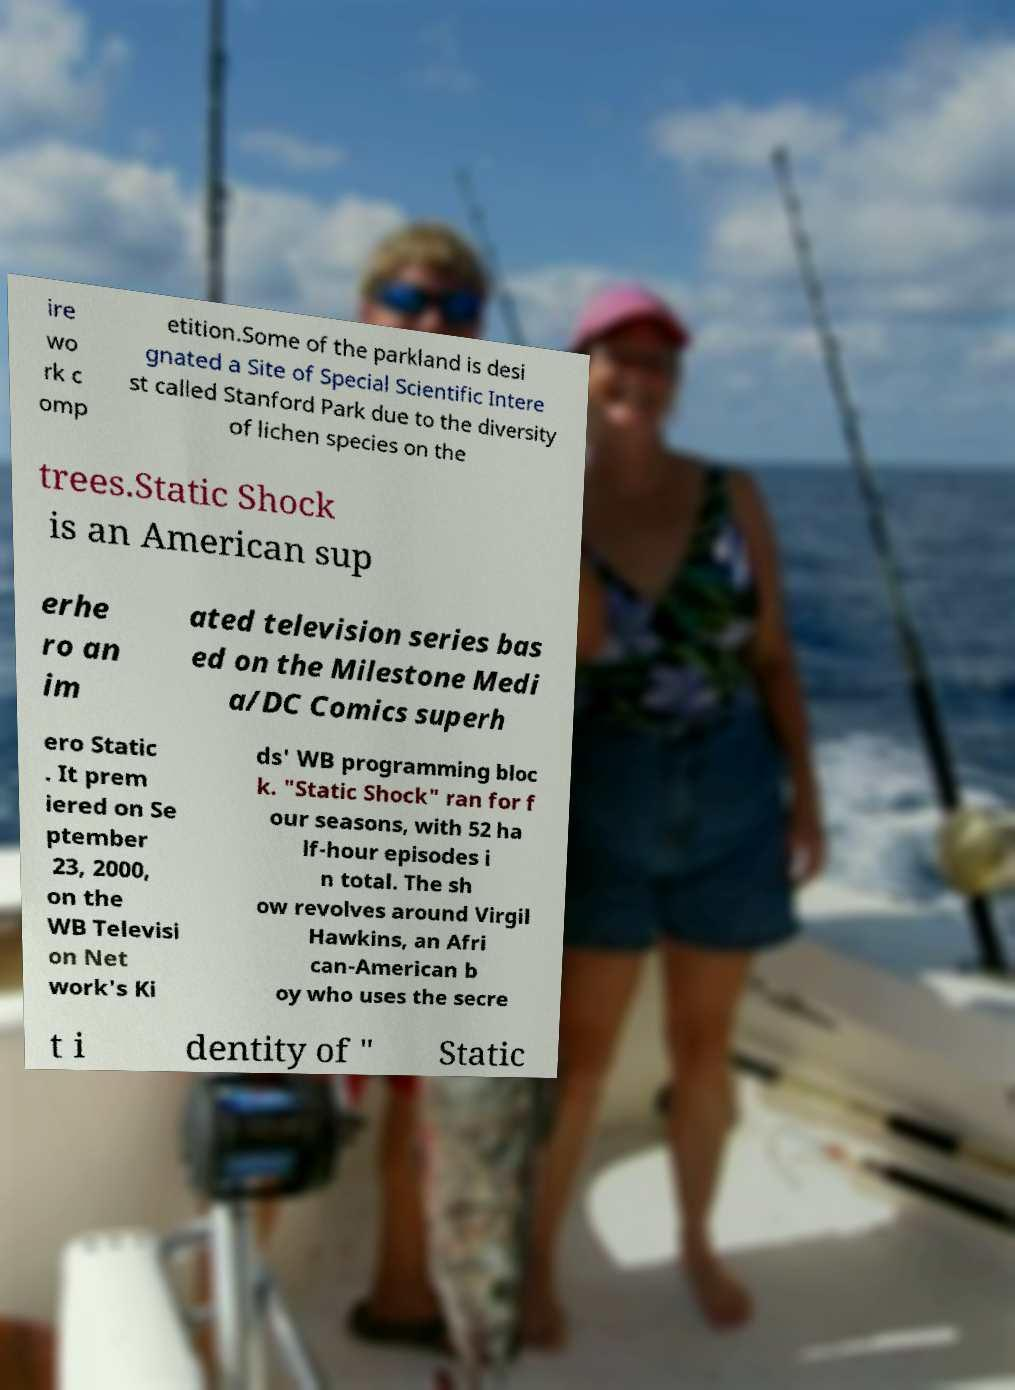Could you extract and type out the text from this image? ire wo rk c omp etition.Some of the parkland is desi gnated a Site of Special Scientific Intere st called Stanford Park due to the diversity of lichen species on the trees.Static Shock is an American sup erhe ro an im ated television series bas ed on the Milestone Medi a/DC Comics superh ero Static . It prem iered on Se ptember 23, 2000, on the WB Televisi on Net work's Ki ds' WB programming bloc k. "Static Shock" ran for f our seasons, with 52 ha lf-hour episodes i n total. The sh ow revolves around Virgil Hawkins, an Afri can-American b oy who uses the secre t i dentity of " Static 